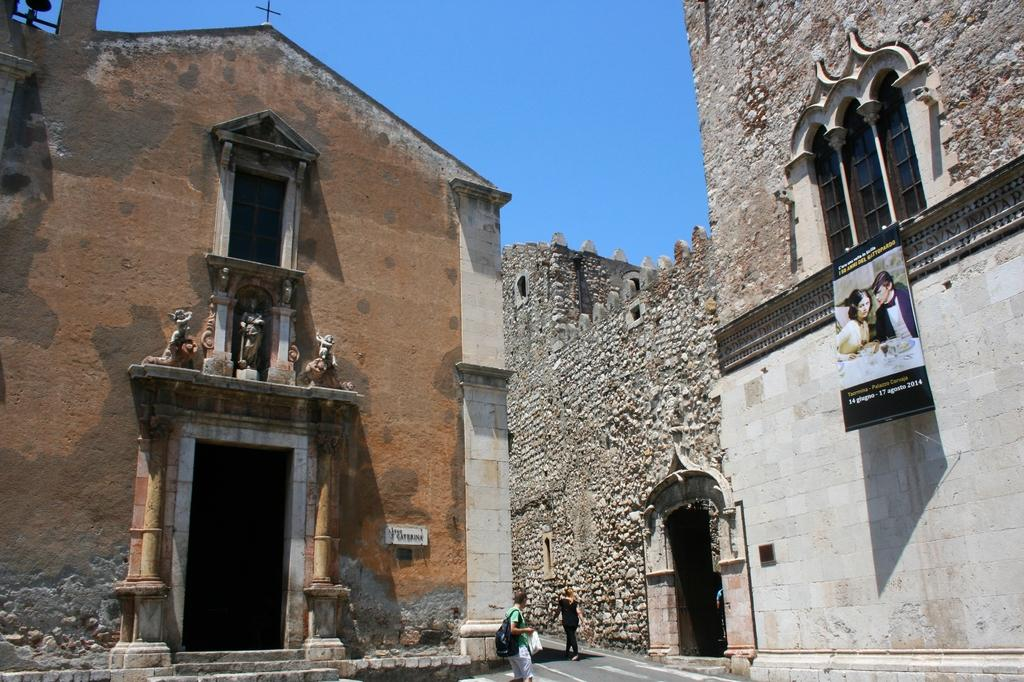What type of structures can be seen in the image? There are buildings in the image. What are the people in the image doing? People are walking on the road in the image. Can you describe the banner that is present in the image? There is a banner with a photo of people and writing on it. What can be seen in the background of the image? The sky is visible in the background of the image. What is the door's motion in the image? There is no door present in the image, so it is not possible to describe its motion. 